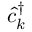Convert formula to latex. <formula><loc_0><loc_0><loc_500><loc_500>\hat { c } _ { k } ^ { \dagger }</formula> 